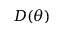Convert formula to latex. <formula><loc_0><loc_0><loc_500><loc_500>D ( \theta )</formula> 